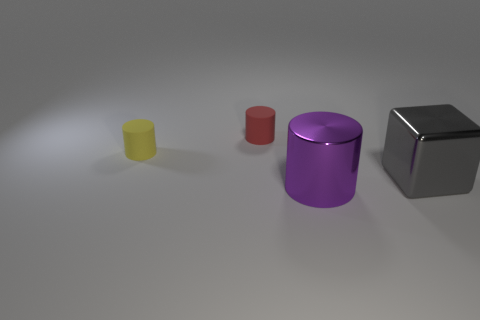What material is the object that is behind the big purple thing and in front of the yellow thing?
Provide a succinct answer. Metal. Are the red thing and the small yellow cylinder made of the same material?
Provide a short and direct response. Yes. What number of yellow objects are there?
Provide a short and direct response. 1. The big thing that is left of the shiny cube behind the large thing in front of the large gray cube is what color?
Provide a succinct answer. Purple. Is the color of the block the same as the metal cylinder?
Offer a terse response. No. How many objects are behind the purple metallic object and to the left of the large gray metal object?
Provide a succinct answer. 2. How many shiny things are either tiny cylinders or purple objects?
Make the answer very short. 1. What is the material of the big thing to the right of the metal object on the left side of the large metallic block?
Make the answer very short. Metal. The gray thing that is the same size as the purple object is what shape?
Keep it short and to the point. Cube. Is the number of small shiny cubes less than the number of metal cubes?
Your answer should be very brief. Yes. 